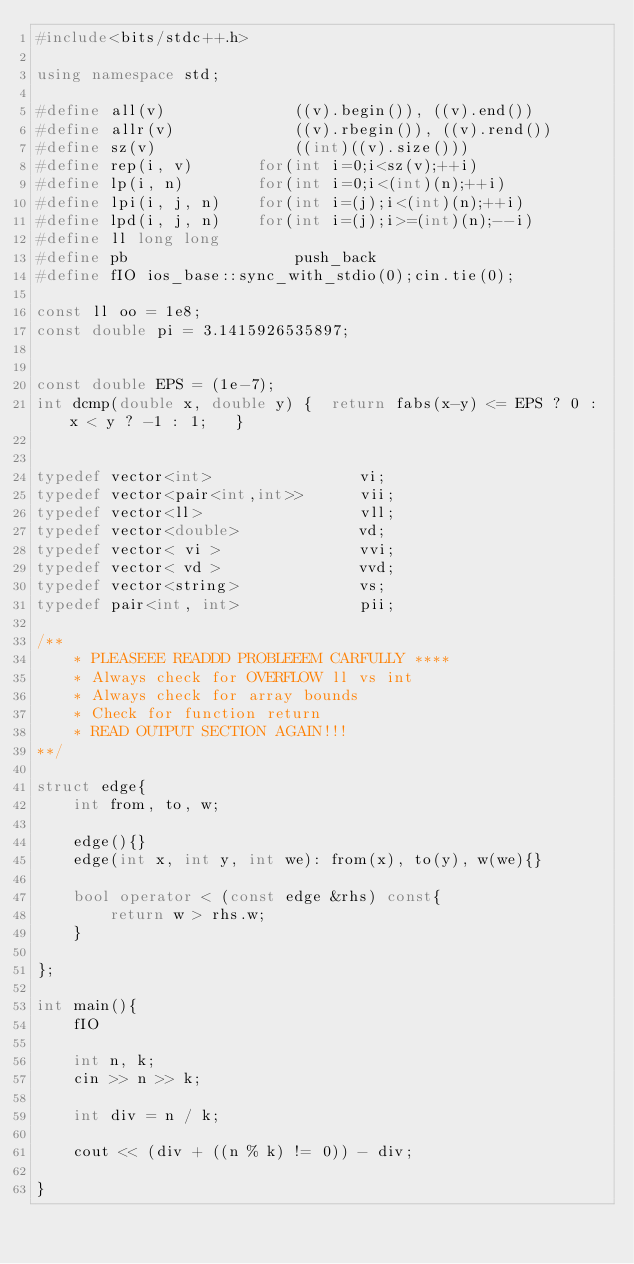Convert code to text. <code><loc_0><loc_0><loc_500><loc_500><_C++_>#include<bits/stdc++.h>

using namespace std;

#define all(v)				((v).begin()), ((v).end())
#define allr(v)				((v).rbegin()), ((v).rend())
#define sz(v)				((int)((v).size()))
#define rep(i, v)		for(int i=0;i<sz(v);++i)
#define lp(i, n)		for(int i=0;i<(int)(n);++i)
#define lpi(i, j, n)	for(int i=(j);i<(int)(n);++i)
#define lpd(i, j, n)	for(int i=(j);i>=(int)(n);--i)
#define ll long long
#define pb					push_back
#define fIO ios_base::sync_with_stdio(0);cin.tie(0);

const ll oo = 1e8;
const double pi = 3.1415926535897;


const double EPS = (1e-7);
int dcmp(double x, double y) {	return fabs(x-y) <= EPS ? 0 : x < y ? -1 : 1;	}


typedef vector<int>                vi;
typedef vector<pair<int,int>>      vii;
typedef vector<ll>                 vll;
typedef vector<double>             vd;
typedef vector< vi >               vvi;
typedef vector< vd >               vvd;
typedef vector<string>             vs;
typedef pair<int, int>             pii;

/**
    * PLEASEEE READDD PROBLEEEM CARFULLY ****
    * Always check for OVERFLOW ll vs int
    * Always check for array bounds
    * Check for function return
    * READ OUTPUT SECTION AGAIN!!!
**/

struct edge{
    int from, to, w;

    edge(){}
    edge(int x, int y, int we): from(x), to(y), w(we){}

    bool operator < (const edge &rhs) const{
        return w > rhs.w;
    }

};

int main(){
    fIO

    int n, k;
    cin >> n >> k;

    int div = n / k;

    cout << (div + ((n % k) != 0)) - div;

}






</code> 